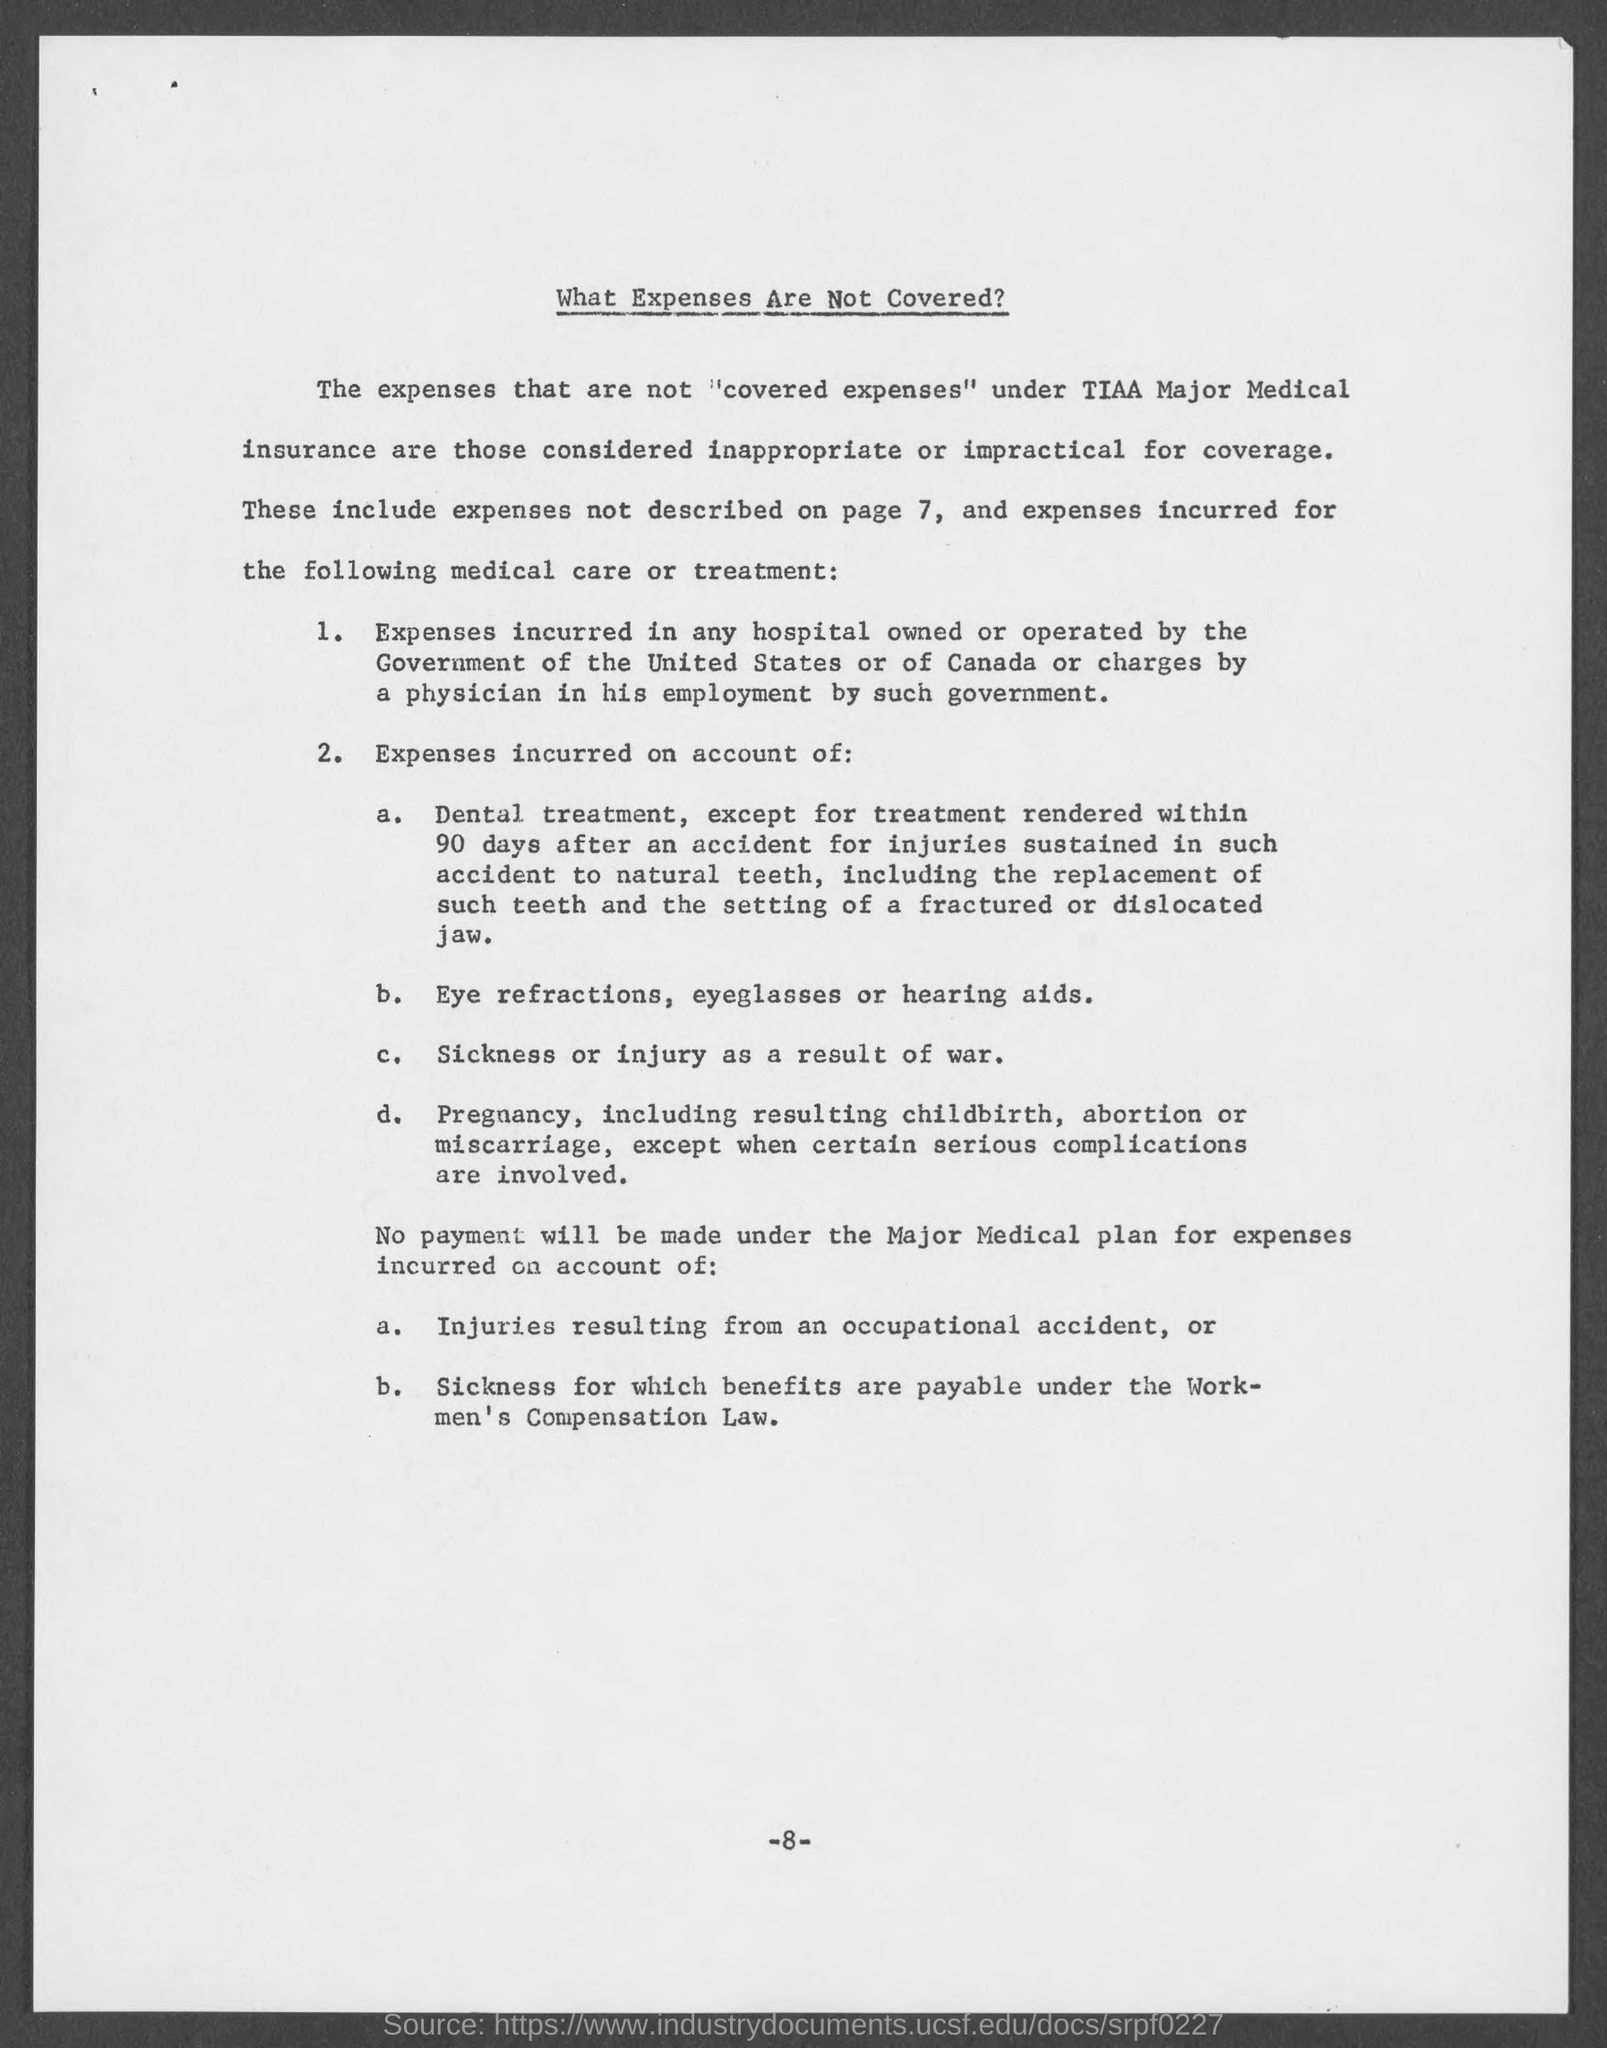Highlight a few significant elements in this photo. The document title provides information on the expenses that are not covered. 